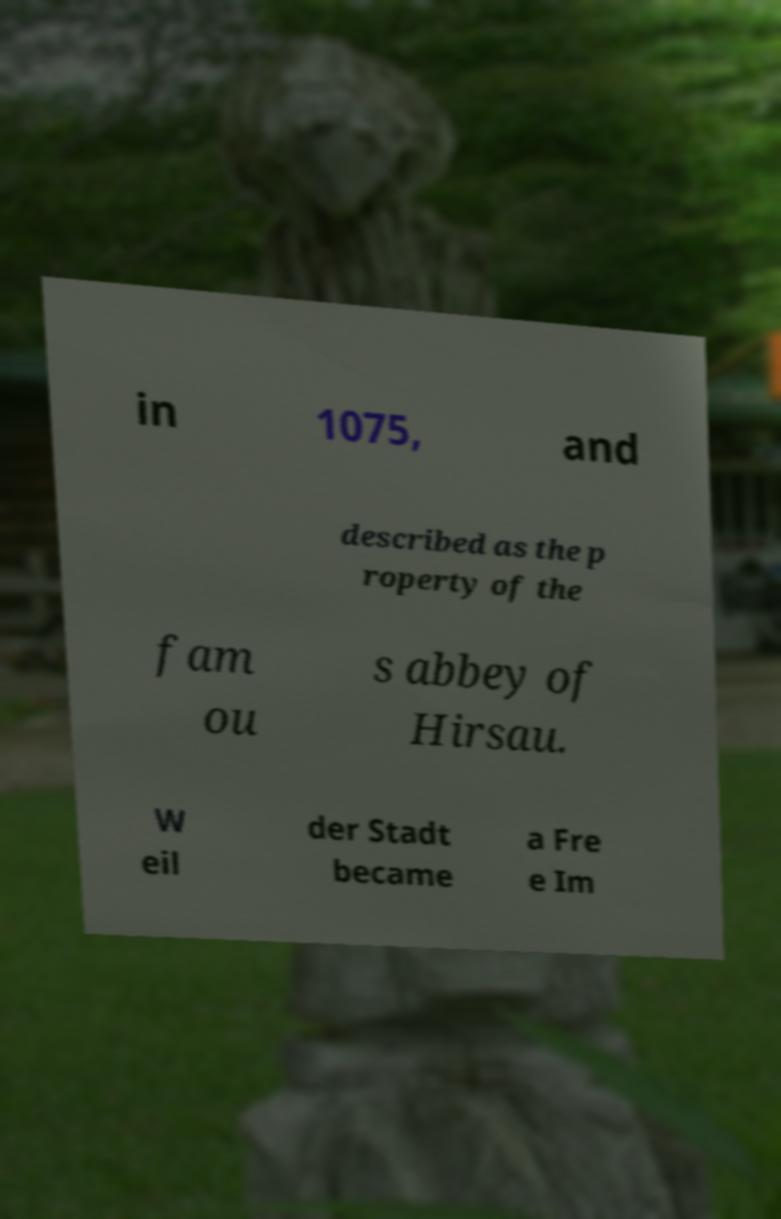I need the written content from this picture converted into text. Can you do that? in 1075, and described as the p roperty of the fam ou s abbey of Hirsau. W eil der Stadt became a Fre e Im 